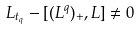Convert formula to latex. <formula><loc_0><loc_0><loc_500><loc_500>L _ { t _ { q } } - [ ( L ^ { q } ) _ { + } , L ] \not = 0</formula> 